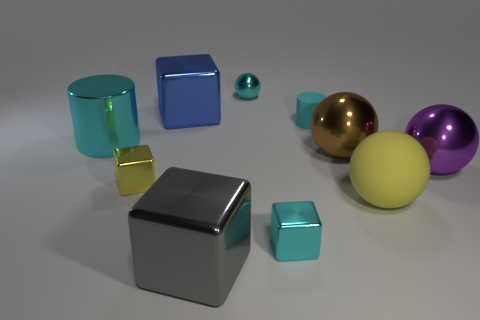Subtract 1 balls. How many balls are left? 3 Subtract all cyan metallic cubes. How many cubes are left? 3 Subtract all yellow balls. How many balls are left? 3 Subtract all green blocks. Subtract all purple balls. How many blocks are left? 4 Subtract all cubes. How many objects are left? 6 Add 3 small cyan metal balls. How many small cyan metal balls exist? 4 Subtract 0 red cubes. How many objects are left? 10 Subtract all small green things. Subtract all tiny rubber cylinders. How many objects are left? 9 Add 6 large yellow rubber spheres. How many large yellow rubber spheres are left? 7 